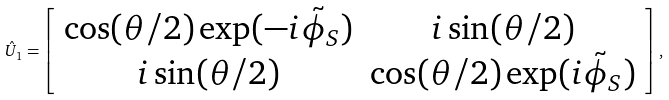<formula> <loc_0><loc_0><loc_500><loc_500>\hat { U } _ { 1 } = \left [ \begin{array} { c c c c } \cos ( \theta / 2 ) \exp ( - i \tilde { \phi } _ { S } ) & i \sin ( \theta / 2 ) \\ i \sin ( \theta / 2 ) & \cos ( \theta / 2 ) \exp ( i \tilde { \phi } _ { S } ) \end{array} \right ] ,</formula> 